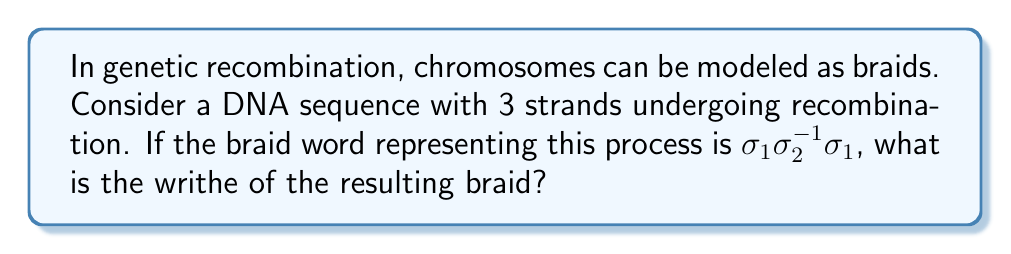Can you solve this math problem? To solve this problem, let's follow these steps:

1) First, recall that the writhe of a braid is the sum of the exponents in its braid word.

2) In our braid word $\sigma_1\sigma_2^{-1}\sigma_1$:
   - $\sigma_1$ appears twice, each with an exponent of 1
   - $\sigma_2^{-1}$ appears once, with an exponent of -1

3) Let's sum these exponents:
   $1 + (-1) + 1 = 1$

4) Therefore, the writhe of this braid is 1.

This concept is relevant to genetic recombination because:
- The writhe provides information about the topology of the DNA strands after recombination.
- A positive writhe indicates a right-handed twist, while a negative writhe indicates a left-handed twist.
- The magnitude of the writhe can give insight into the complexity of the recombination event.

For a bioinformatician, understanding these topological properties can be crucial when developing algorithms to analyze or predict genetic recombination events.
Answer: 1 